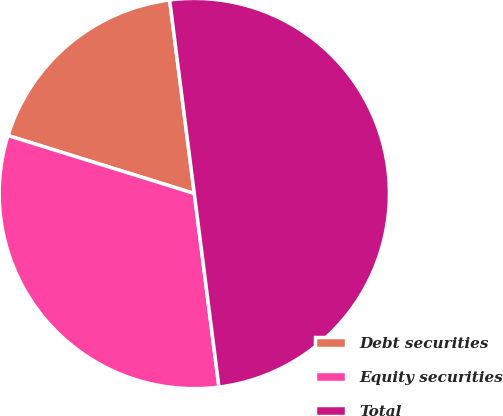<chart> <loc_0><loc_0><loc_500><loc_500><pie_chart><fcel>Debt securities<fcel>Equity securities<fcel>Total<nl><fcel>18.18%<fcel>31.82%<fcel>50.0%<nl></chart> 